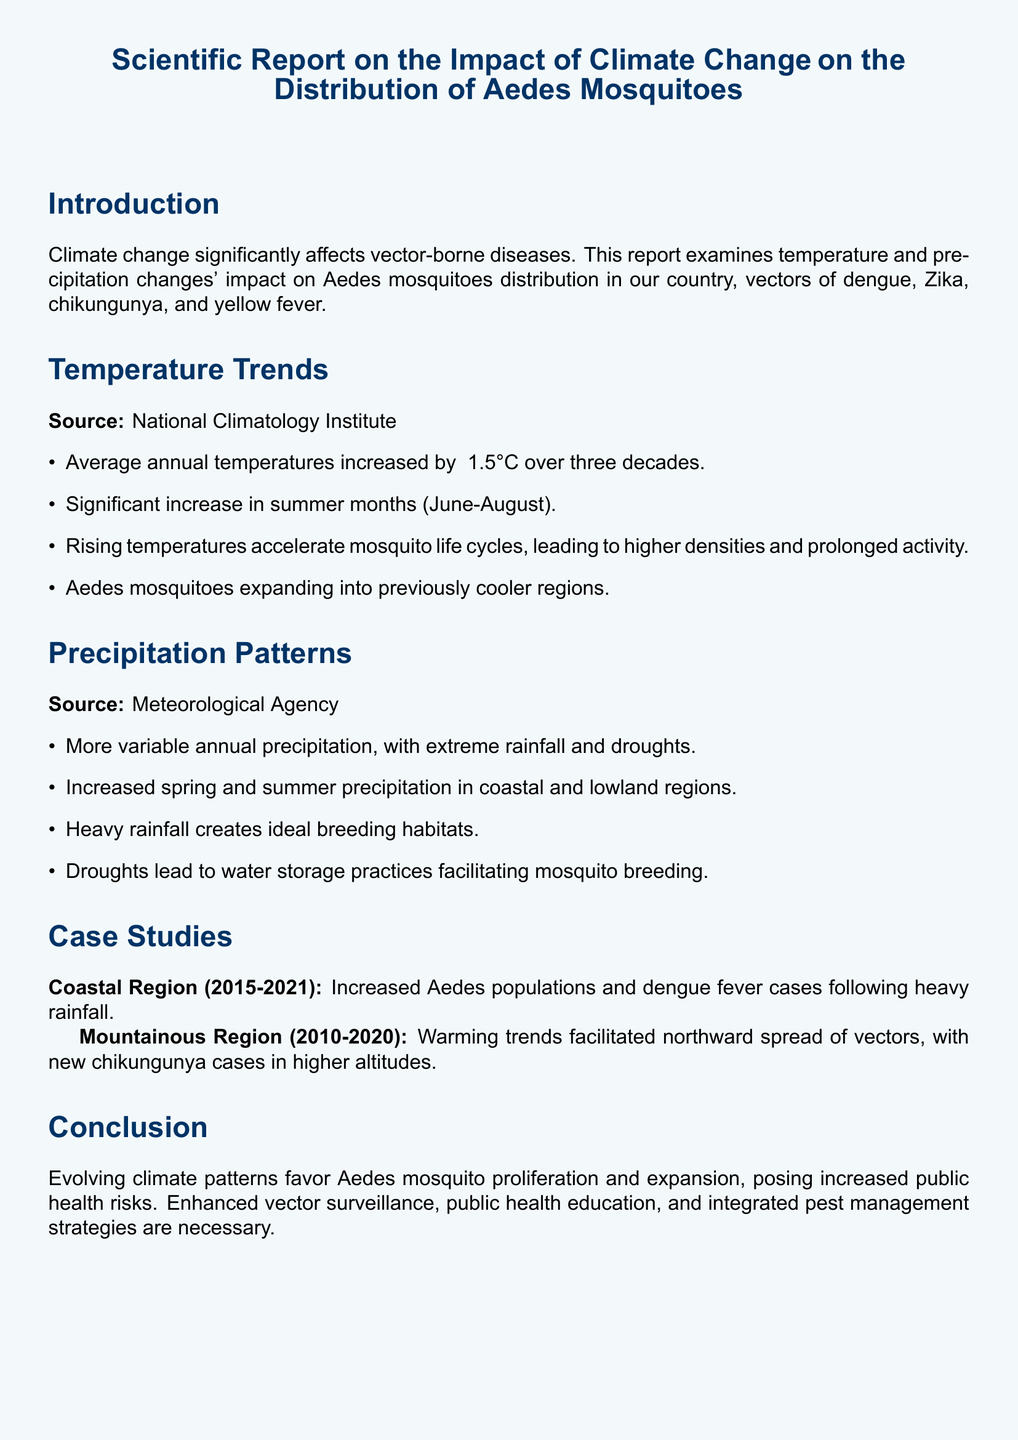What is the average annual temperature increase over three decades? The average annual temperature increase is mentioned in the report as ~1.5°C which summarizes the trend observed during that period.
Answer: ~1.5°C What is the source for temperature trends? The document specifies that the source for temperature trends is the National Climatology Institute, which is relevant to understanding where the data originates.
Answer: National Climatology Institute What region is mentioned for the northward spread of Aedes mosquitoes? The mountainous region is discussed in relation to the northward spread of Aedes mosquitoes due to warming trends, linking environmental changes to vector behavior.
Answer: Mountainous Region Which months show a significant increase in temperature? The summer months (June-August) are highlighted in the document as periods of notable temperature increase, indicating seasonal variations.
Answer: June-August How should public health engage according to the recommendations? The document emphasizes community engagement in mosquito control efforts, suggesting a participatory approach to public health strategies.
Answer: Community engagement What does heavy rainfall create for Aedes mosquitoes? The report states that heavy rainfall creates ideal breeding habitats, which is critical for understanding mosquito population dynamics.
Answer: Ideal breeding habitats What disease is specifically associated with increased Aedes populations in coastal regions from 2015-2021? The document mentions dengue fever cases in relation to increased Aedes populations in the coastal region during the specified period, clarifying the impact of vector presence on health outcomes.
Answer: Dengue fever What is one of the main public health risks posed by climate change mentioned in the conclusion? The report indicates that the proliferation and expansion of Aedes mosquitoes due to climate change poses increased public health risks for vector-borne diseases.
Answer: Increased public health risks 